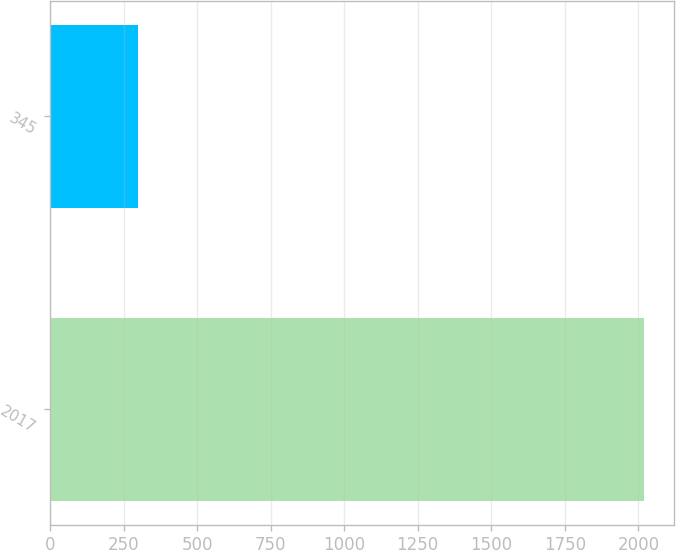Convert chart. <chart><loc_0><loc_0><loc_500><loc_500><bar_chart><fcel>2017<fcel>345<nl><fcel>2021<fcel>298<nl></chart> 